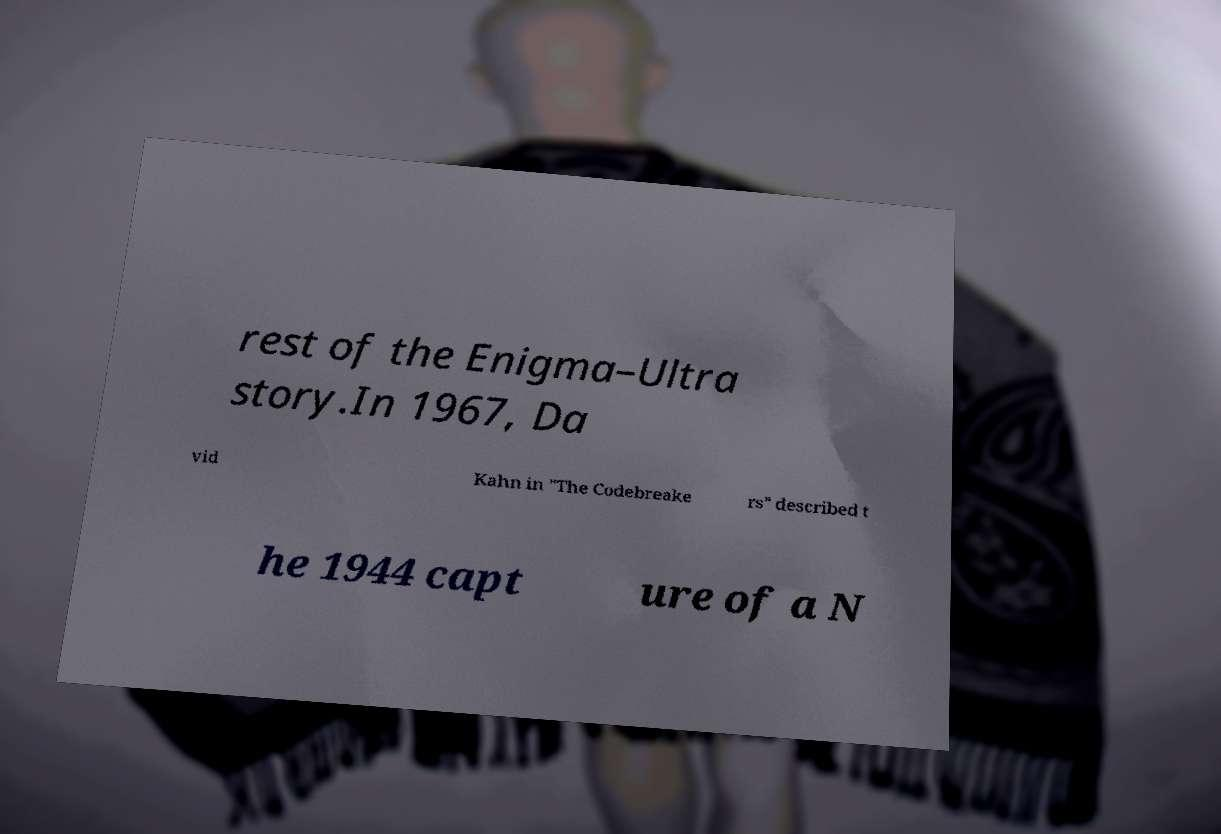For documentation purposes, I need the text within this image transcribed. Could you provide that? rest of the Enigma–Ultra story.In 1967, Da vid Kahn in "The Codebreake rs" described t he 1944 capt ure of a N 